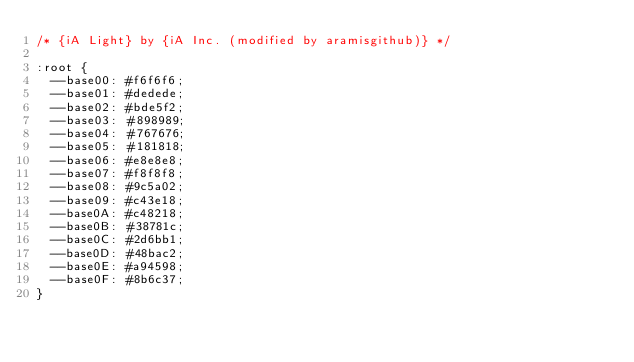Convert code to text. <code><loc_0><loc_0><loc_500><loc_500><_CSS_>/* {iA Light} by {iA Inc. (modified by aramisgithub)} */

:root {
  --base00: #f6f6f6;
  --base01: #dedede;
  --base02: #bde5f2;
  --base03: #898989;
  --base04: #767676;
  --base05: #181818;
  --base06: #e8e8e8;
  --base07: #f8f8f8;
  --base08: #9c5a02;
  --base09: #c43e18;
  --base0A: #c48218;
  --base0B: #38781c;
  --base0C: #2d6bb1;
  --base0D: #48bac2;
  --base0E: #a94598;
  --base0F: #8b6c37;
}
</code> 